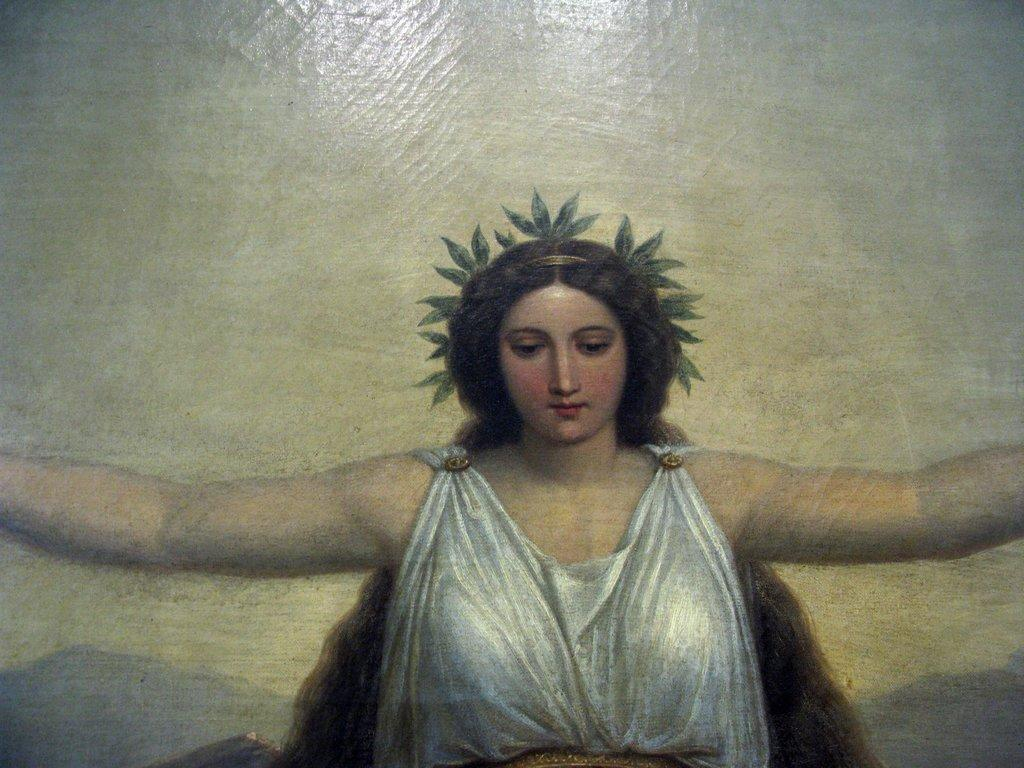What is the main subject of the image? There is a painting in the image. What is the painting depicting? The painting depicts a woman. What is the woman wearing in the painting? The woman is wearing a white dress. What type of underwear is the woman wearing in the painting? The provided facts do not mention any underwear, so we cannot determine what type the woman might be wearing in the painting. 